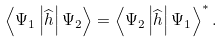<formula> <loc_0><loc_0><loc_500><loc_500>\left \langle \Psi _ { 1 } \left | \widehat { h } \right | \Psi _ { 2 } \right \rangle = \left \langle \Psi _ { 2 } \left | \widehat { h } \right | \Psi _ { 1 } \right \rangle ^ { \ast } .</formula> 